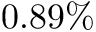<formula> <loc_0><loc_0><loc_500><loc_500>0 . 8 9 \%</formula> 